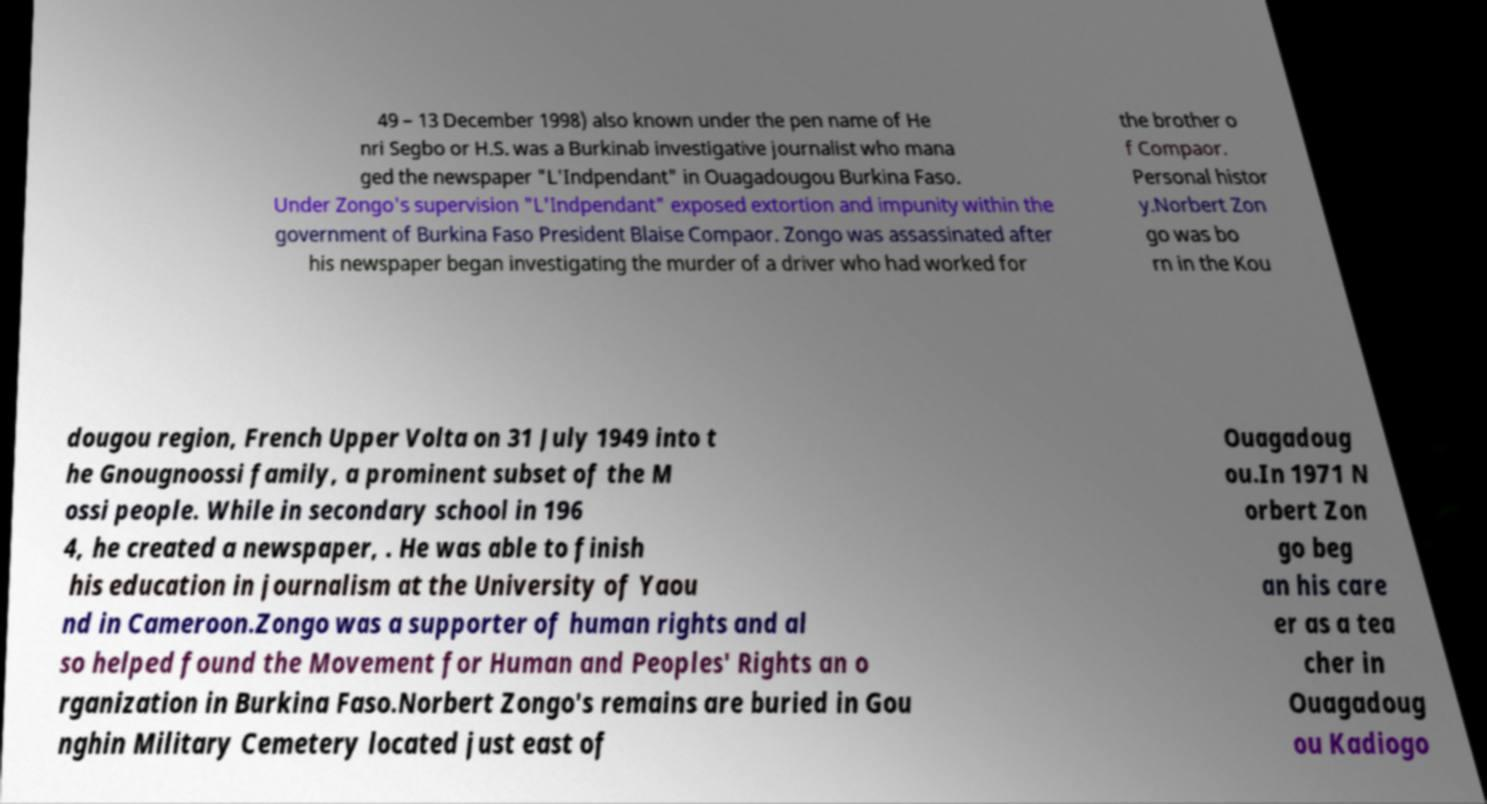For documentation purposes, I need the text within this image transcribed. Could you provide that? 49 – 13 December 1998) also known under the pen name of He nri Segbo or H.S. was a Burkinab investigative journalist who mana ged the newspaper "L'Indpendant" in Ouagadougou Burkina Faso. Under Zongo's supervision "L'Indpendant" exposed extortion and impunity within the government of Burkina Faso President Blaise Compaor. Zongo was assassinated after his newspaper began investigating the murder of a driver who had worked for the brother o f Compaor. Personal histor y.Norbert Zon go was bo rn in the Kou dougou region, French Upper Volta on 31 July 1949 into t he Gnougnoossi family, a prominent subset of the M ossi people. While in secondary school in 196 4, he created a newspaper, . He was able to finish his education in journalism at the University of Yaou nd in Cameroon.Zongo was a supporter of human rights and al so helped found the Movement for Human and Peoples' Rights an o rganization in Burkina Faso.Norbert Zongo's remains are buried in Gou nghin Military Cemetery located just east of Ouagadoug ou.In 1971 N orbert Zon go beg an his care er as a tea cher in Ouagadoug ou Kadiogo 